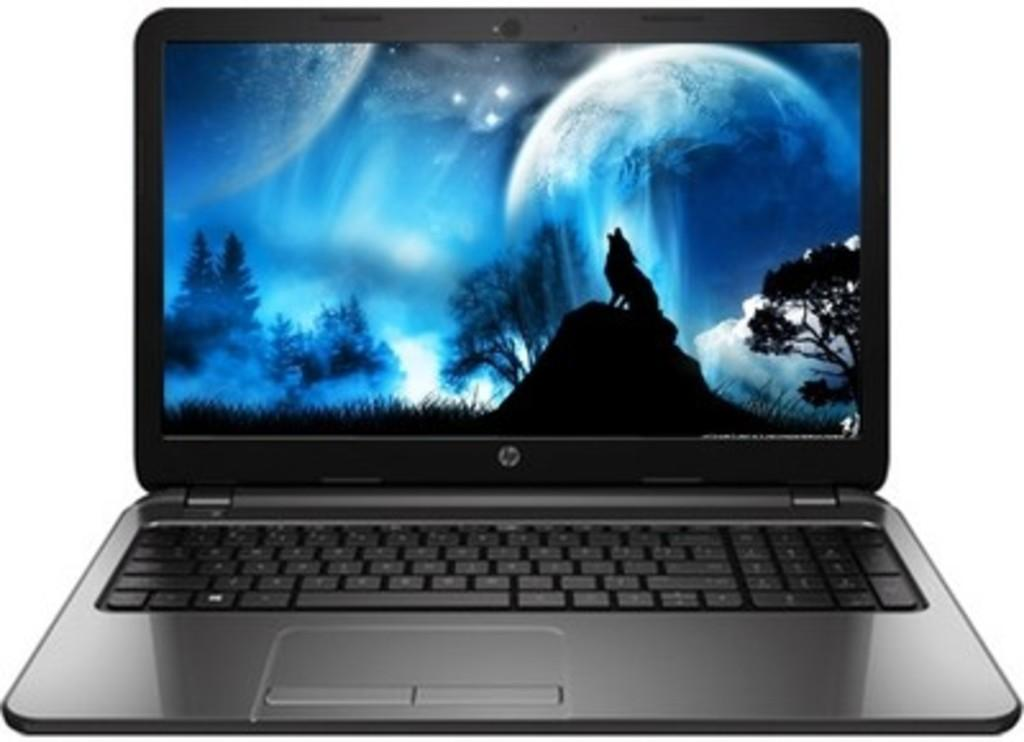What electronic device is visible in the image? There is a laptop in the image. What is displayed on the laptop screen? The laptop screen displays an animal and trees. What type of lettuce is being used as a comfort item in the image? There is no lettuce present in the image, and no comfort item is mentioned. 